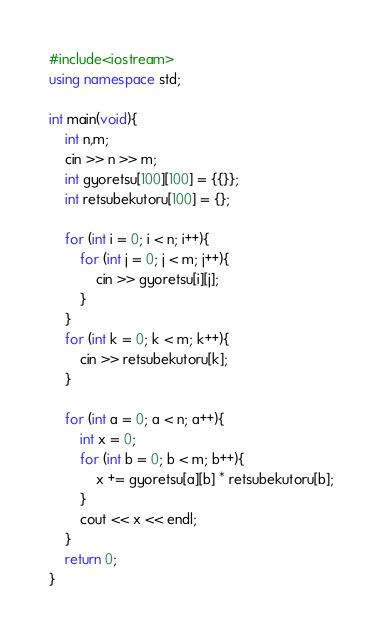Convert code to text. <code><loc_0><loc_0><loc_500><loc_500><_C++_>#include<iostream>
using namespace std;

int main(void){
    int n,m;
    cin >> n >> m;
    int gyoretsu[100][100] = {{}};
    int retsubekutoru[100] = {};
    
    for (int i = 0; i < n; i++){
        for (int j = 0; j < m; j++){
            cin >> gyoretsu[i][j];
        }
    }
    for (int k = 0; k < m; k++){
        cin >> retsubekutoru[k];
    }
    
    for (int a = 0; a < n; a++){
        int x = 0;
        for (int b = 0; b < m; b++){
            x += gyoretsu[a][b] * retsubekutoru[b];
        }
        cout << x << endl; 
    }
    return 0;
}

</code> 